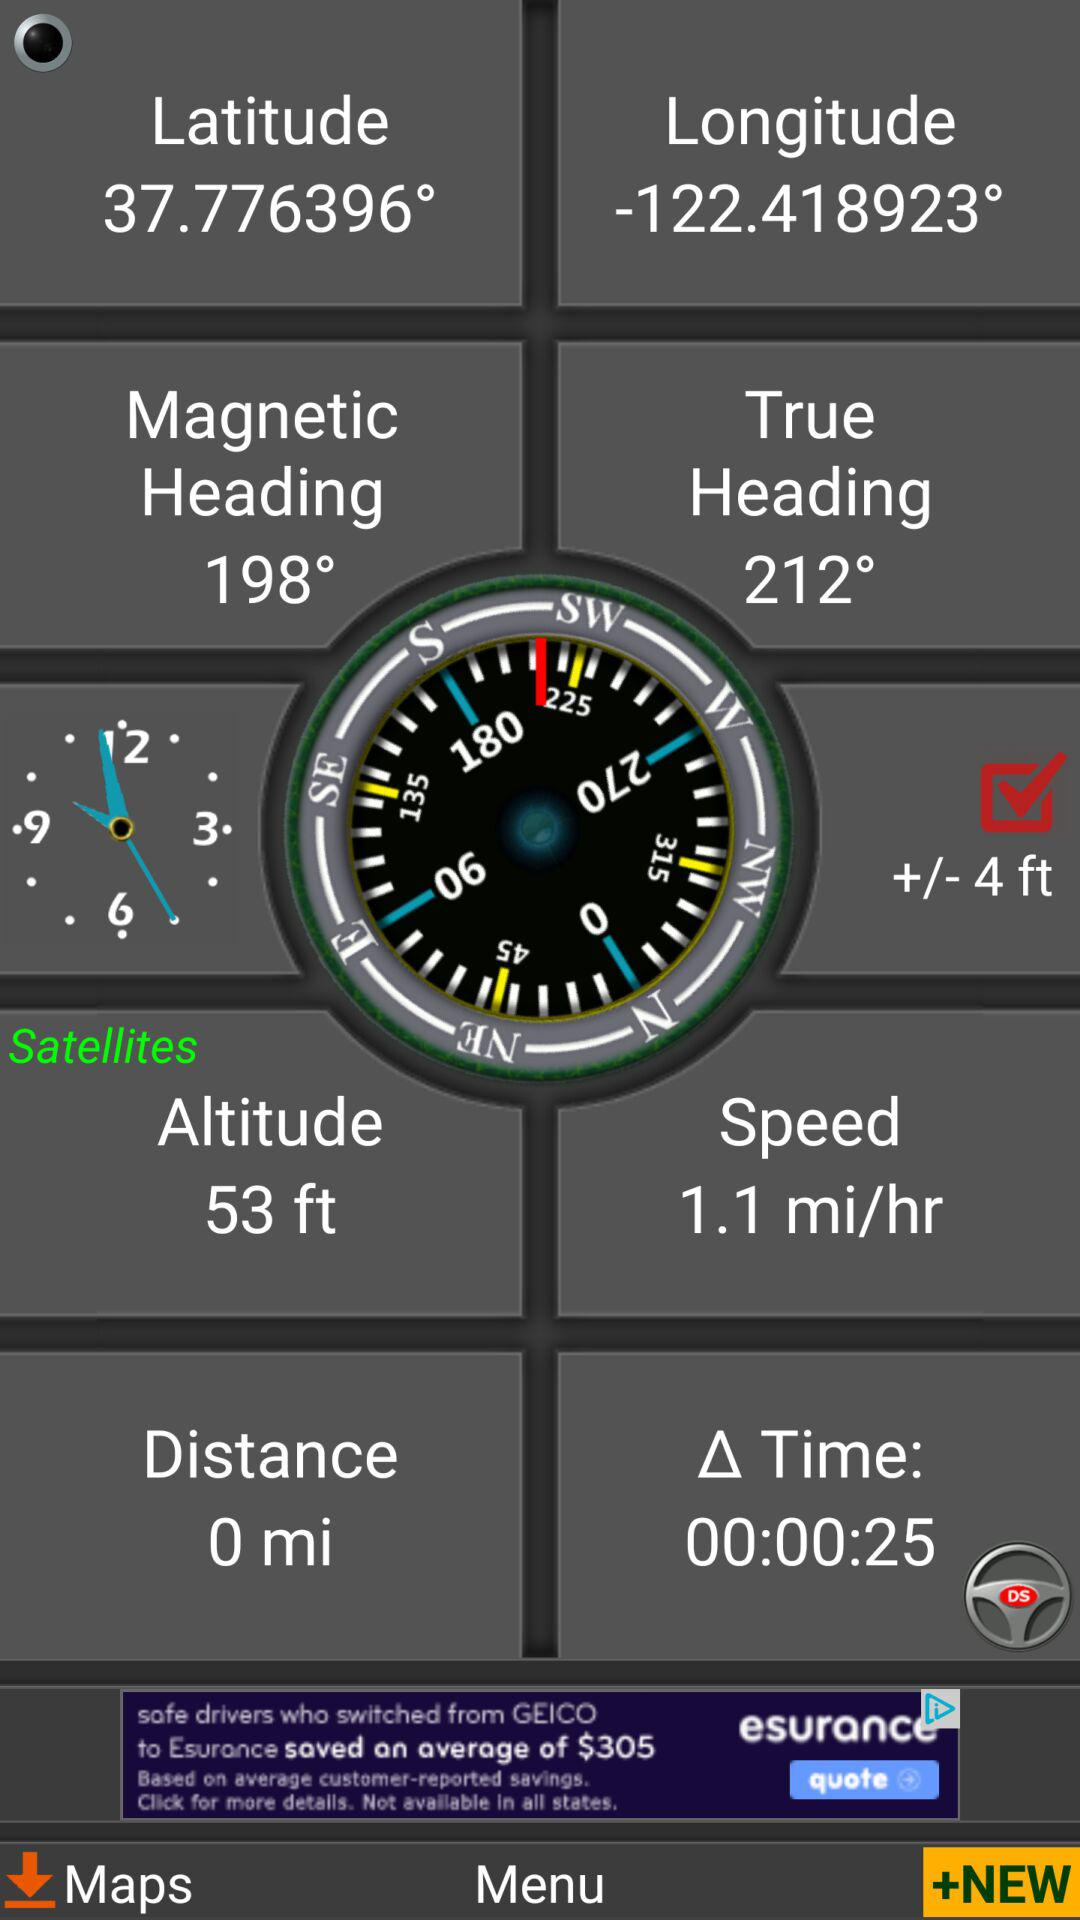How many degrees is the difference between the magnetic and true headings?
Answer the question using a single word or phrase. 14° 